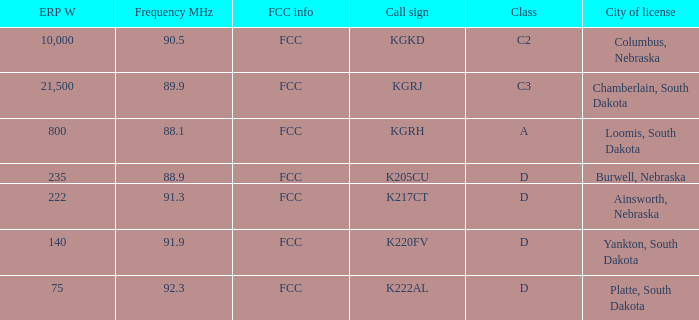What is the sum of the erp w of the k222al call sign? 75.0. 